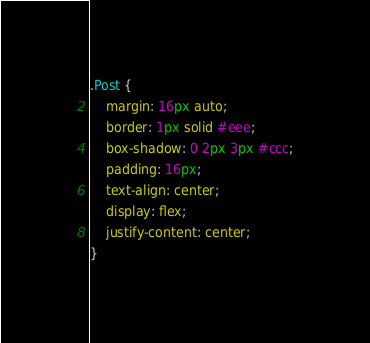Convert code to text. <code><loc_0><loc_0><loc_500><loc_500><_CSS_>.Post {
	margin: 16px auto;
	border: 1px solid #eee;
	box-shadow: 0 2px 3px #ccc;
	padding: 16px;
	text-align: center;
	display: flex;
	justify-content: center;
}</code> 